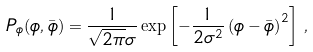Convert formula to latex. <formula><loc_0><loc_0><loc_500><loc_500>P _ { \phi } ( \phi , \bar { \phi } ) = \frac { 1 } { \sqrt { 2 \pi } \sigma } \exp \left [ - \frac { 1 } { 2 \sigma ^ { 2 } } \left ( \phi - \bar { \phi } \right ) ^ { 2 } \right ] \, ,</formula> 